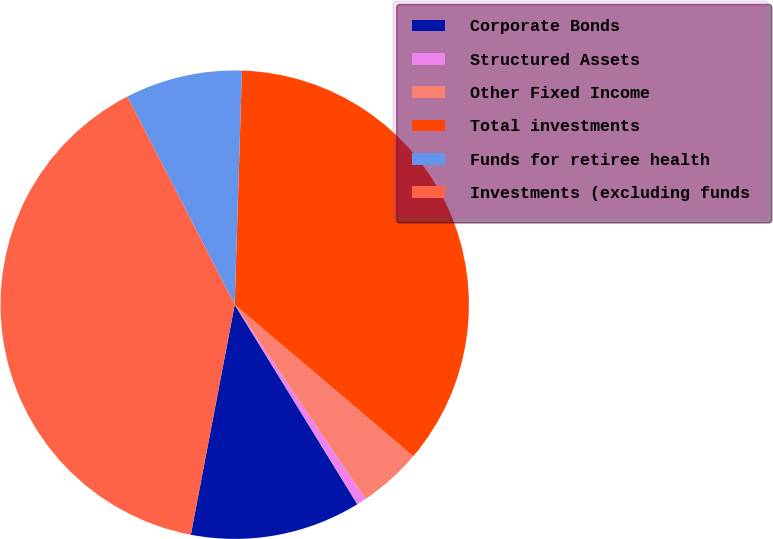Convert chart to OTSL. <chart><loc_0><loc_0><loc_500><loc_500><pie_chart><fcel>Corporate Bonds<fcel>Structured Assets<fcel>Other Fixed Income<fcel>Total investments<fcel>Funds for retiree health<fcel>Investments (excluding funds<nl><fcel>11.77%<fcel>0.66%<fcel>4.37%<fcel>35.71%<fcel>8.07%<fcel>39.42%<nl></chart> 